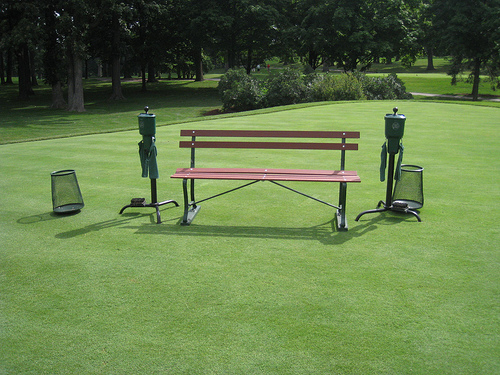<image>
Is there a grass under the bench? Yes. The grass is positioned underneath the bench, with the bench above it in the vertical space. 